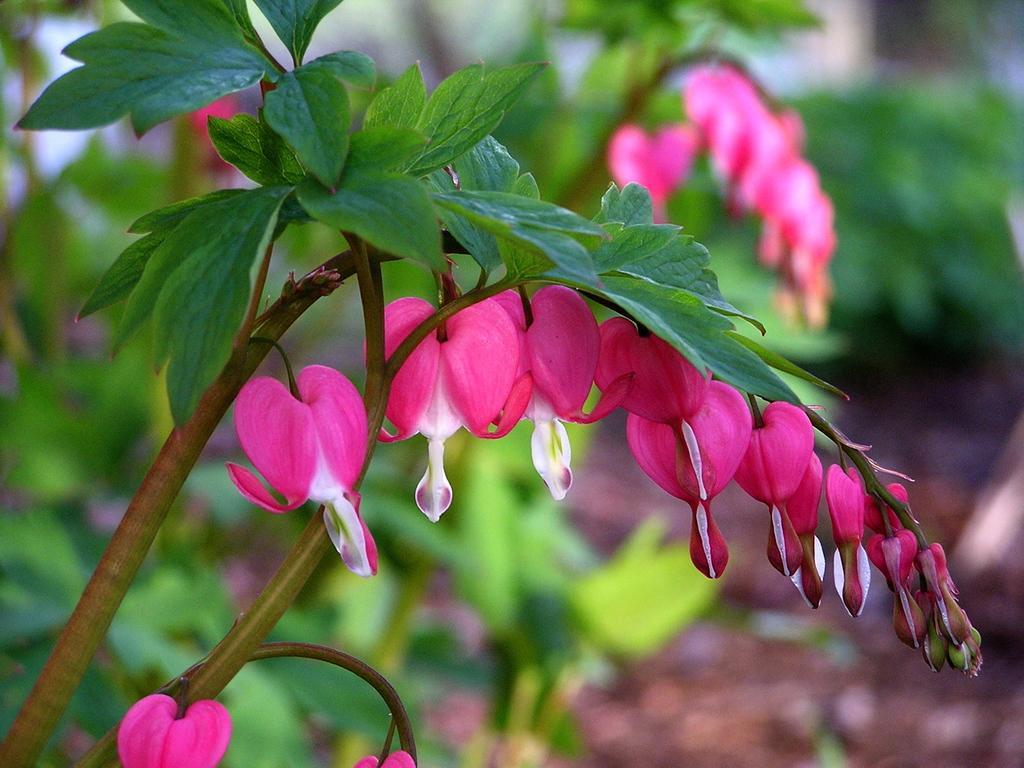Could you give a brief overview of what you see in this image? In this image I can see a tree which is green and brown in color and few flowers to it which are pink and white in color. In the background I can see few trees and the ground. 